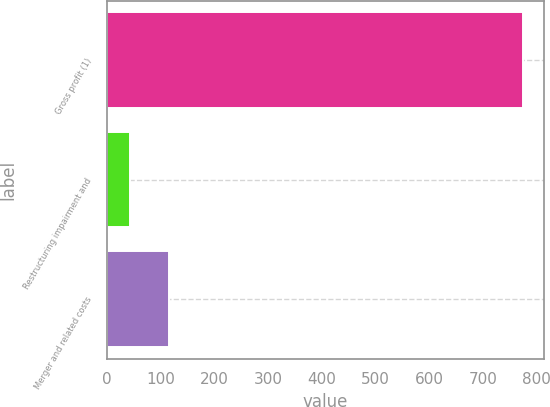<chart> <loc_0><loc_0><loc_500><loc_500><bar_chart><fcel>Gross profit (1)<fcel>Restructuring impairment and<fcel>Merger and related costs<nl><fcel>775<fcel>42<fcel>115.3<nl></chart> 